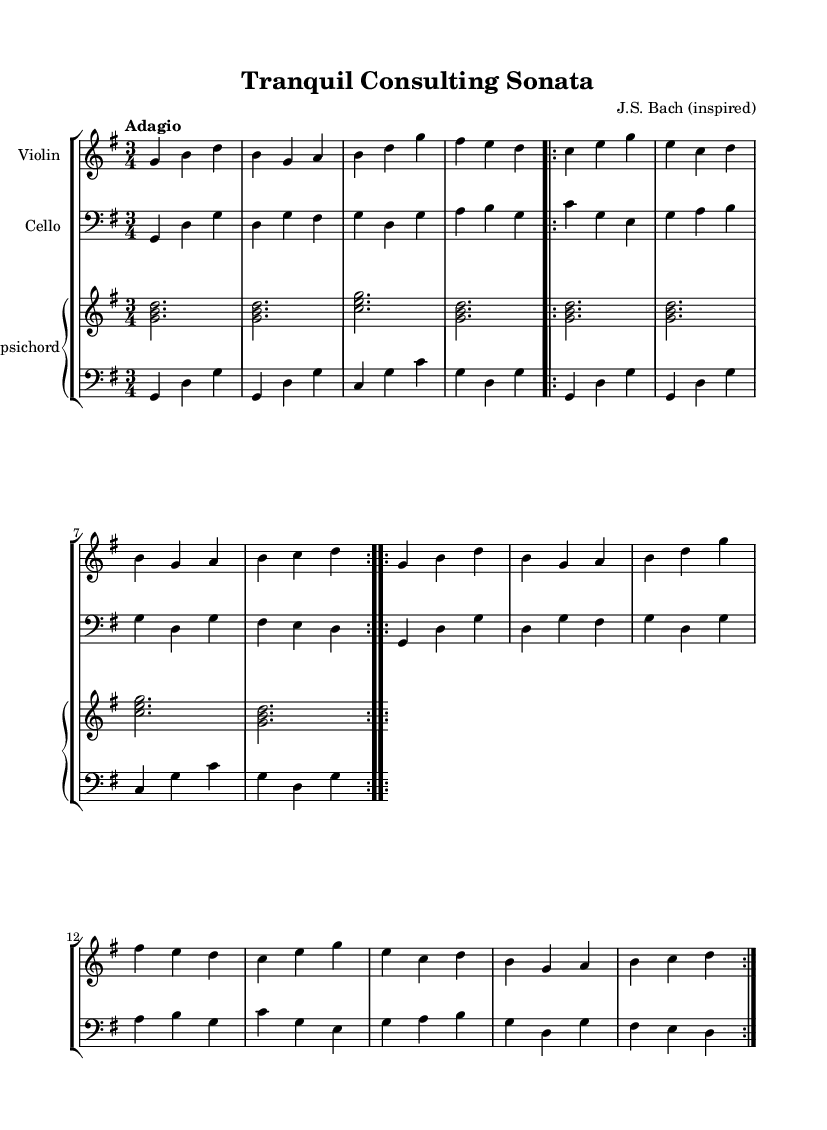What is the key signature of this music? The key signature is G major, which has one sharp (F#).
Answer: G major What is the time signature of this music? The time signature is 3/4, which means there are three beats per measure.
Answer: 3/4 What is the tempo marking indicated in the music? The tempo marking indicates "Adagio," which suggests a slow and relaxed pace.
Answer: Adagio How many measures are in the repeated section of violin? The repeated section of the violin consists of 8 measures, as indicated by the use of the repeat volta.
Answer: 8 measures What instruments are used in this piece? The music features a violin, a cello, and a harpsichord, as shown in the score's instrumentation.
Answer: Violin, cello, harpsichord What is the primary texture of this Baroque piece? The primary texture is homophonic, featuring a clear melody accompanied by harmonic support from the other instruments.
Answer: Homophonic How many times does the cello part repeat in the entire score? The cello part repeats twice in the piece, as indicated by the repeat markings applied to it.
Answer: Twice 